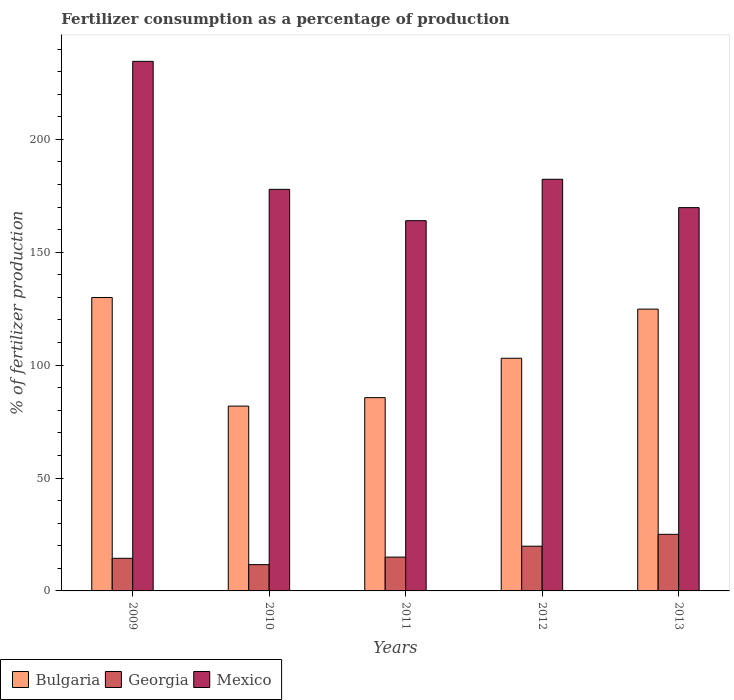How many groups of bars are there?
Provide a succinct answer. 5. Are the number of bars per tick equal to the number of legend labels?
Provide a succinct answer. Yes. Are the number of bars on each tick of the X-axis equal?
Keep it short and to the point. Yes. How many bars are there on the 2nd tick from the right?
Offer a very short reply. 3. What is the label of the 1st group of bars from the left?
Ensure brevity in your answer.  2009. What is the percentage of fertilizers consumed in Mexico in 2011?
Your answer should be compact. 163.98. Across all years, what is the maximum percentage of fertilizers consumed in Georgia?
Offer a very short reply. 25.07. Across all years, what is the minimum percentage of fertilizers consumed in Bulgaria?
Your response must be concise. 81.87. In which year was the percentage of fertilizers consumed in Mexico maximum?
Your answer should be compact. 2009. What is the total percentage of fertilizers consumed in Georgia in the graph?
Provide a short and direct response. 85.94. What is the difference between the percentage of fertilizers consumed in Georgia in 2012 and that in 2013?
Your answer should be compact. -5.26. What is the difference between the percentage of fertilizers consumed in Mexico in 2009 and the percentage of fertilizers consumed in Georgia in 2013?
Keep it short and to the point. 209.49. What is the average percentage of fertilizers consumed in Bulgaria per year?
Keep it short and to the point. 105.06. In the year 2010, what is the difference between the percentage of fertilizers consumed in Georgia and percentage of fertilizers consumed in Bulgaria?
Keep it short and to the point. -70.22. What is the ratio of the percentage of fertilizers consumed in Mexico in 2009 to that in 2013?
Your answer should be very brief. 1.38. Is the percentage of fertilizers consumed in Georgia in 2010 less than that in 2011?
Give a very brief answer. Yes. What is the difference between the highest and the second highest percentage of fertilizers consumed in Bulgaria?
Your response must be concise. 5.15. What is the difference between the highest and the lowest percentage of fertilizers consumed in Mexico?
Offer a terse response. 70.58. In how many years, is the percentage of fertilizers consumed in Bulgaria greater than the average percentage of fertilizers consumed in Bulgaria taken over all years?
Ensure brevity in your answer.  2. What does the 2nd bar from the right in 2011 represents?
Provide a short and direct response. Georgia. Is it the case that in every year, the sum of the percentage of fertilizers consumed in Bulgaria and percentage of fertilizers consumed in Mexico is greater than the percentage of fertilizers consumed in Georgia?
Make the answer very short. Yes. How many bars are there?
Provide a short and direct response. 15. What is the difference between two consecutive major ticks on the Y-axis?
Provide a succinct answer. 50. Are the values on the major ticks of Y-axis written in scientific E-notation?
Offer a very short reply. No. Does the graph contain any zero values?
Make the answer very short. No. Does the graph contain grids?
Ensure brevity in your answer.  No. Where does the legend appear in the graph?
Provide a short and direct response. Bottom left. How are the legend labels stacked?
Ensure brevity in your answer.  Horizontal. What is the title of the graph?
Your response must be concise. Fertilizer consumption as a percentage of production. What is the label or title of the X-axis?
Give a very brief answer. Years. What is the label or title of the Y-axis?
Your answer should be very brief. % of fertilizer production. What is the % of fertilizer production of Bulgaria in 2009?
Keep it short and to the point. 129.97. What is the % of fertilizer production of Georgia in 2009?
Offer a very short reply. 14.44. What is the % of fertilizer production of Mexico in 2009?
Provide a succinct answer. 234.56. What is the % of fertilizer production in Bulgaria in 2010?
Your answer should be compact. 81.87. What is the % of fertilizer production of Georgia in 2010?
Give a very brief answer. 11.64. What is the % of fertilizer production of Mexico in 2010?
Offer a very short reply. 177.87. What is the % of fertilizer production in Bulgaria in 2011?
Your answer should be very brief. 85.6. What is the % of fertilizer production of Georgia in 2011?
Give a very brief answer. 14.98. What is the % of fertilizer production of Mexico in 2011?
Ensure brevity in your answer.  163.98. What is the % of fertilizer production of Bulgaria in 2012?
Ensure brevity in your answer.  103.06. What is the % of fertilizer production in Georgia in 2012?
Provide a succinct answer. 19.81. What is the % of fertilizer production in Mexico in 2012?
Your answer should be very brief. 182.33. What is the % of fertilizer production in Bulgaria in 2013?
Your answer should be compact. 124.82. What is the % of fertilizer production in Georgia in 2013?
Provide a short and direct response. 25.07. What is the % of fertilizer production of Mexico in 2013?
Offer a very short reply. 169.77. Across all years, what is the maximum % of fertilizer production of Bulgaria?
Your answer should be compact. 129.97. Across all years, what is the maximum % of fertilizer production in Georgia?
Offer a terse response. 25.07. Across all years, what is the maximum % of fertilizer production in Mexico?
Provide a short and direct response. 234.56. Across all years, what is the minimum % of fertilizer production in Bulgaria?
Give a very brief answer. 81.87. Across all years, what is the minimum % of fertilizer production of Georgia?
Keep it short and to the point. 11.64. Across all years, what is the minimum % of fertilizer production of Mexico?
Ensure brevity in your answer.  163.98. What is the total % of fertilizer production in Bulgaria in the graph?
Give a very brief answer. 525.31. What is the total % of fertilizer production of Georgia in the graph?
Offer a terse response. 85.94. What is the total % of fertilizer production of Mexico in the graph?
Your response must be concise. 928.52. What is the difference between the % of fertilizer production of Bulgaria in 2009 and that in 2010?
Give a very brief answer. 48.1. What is the difference between the % of fertilizer production in Georgia in 2009 and that in 2010?
Your answer should be compact. 2.8. What is the difference between the % of fertilizer production in Mexico in 2009 and that in 2010?
Ensure brevity in your answer.  56.68. What is the difference between the % of fertilizer production of Bulgaria in 2009 and that in 2011?
Ensure brevity in your answer.  44.36. What is the difference between the % of fertilizer production of Georgia in 2009 and that in 2011?
Provide a succinct answer. -0.54. What is the difference between the % of fertilizer production of Mexico in 2009 and that in 2011?
Your answer should be compact. 70.58. What is the difference between the % of fertilizer production in Bulgaria in 2009 and that in 2012?
Offer a terse response. 26.91. What is the difference between the % of fertilizer production of Georgia in 2009 and that in 2012?
Make the answer very short. -5.37. What is the difference between the % of fertilizer production in Mexico in 2009 and that in 2012?
Offer a very short reply. 52.23. What is the difference between the % of fertilizer production in Bulgaria in 2009 and that in 2013?
Make the answer very short. 5.15. What is the difference between the % of fertilizer production of Georgia in 2009 and that in 2013?
Provide a short and direct response. -10.62. What is the difference between the % of fertilizer production of Mexico in 2009 and that in 2013?
Give a very brief answer. 64.78. What is the difference between the % of fertilizer production in Bulgaria in 2010 and that in 2011?
Offer a very short reply. -3.74. What is the difference between the % of fertilizer production in Georgia in 2010 and that in 2011?
Give a very brief answer. -3.34. What is the difference between the % of fertilizer production in Mexico in 2010 and that in 2011?
Offer a very short reply. 13.89. What is the difference between the % of fertilizer production of Bulgaria in 2010 and that in 2012?
Ensure brevity in your answer.  -21.19. What is the difference between the % of fertilizer production in Georgia in 2010 and that in 2012?
Provide a succinct answer. -8.17. What is the difference between the % of fertilizer production of Mexico in 2010 and that in 2012?
Ensure brevity in your answer.  -4.46. What is the difference between the % of fertilizer production in Bulgaria in 2010 and that in 2013?
Your answer should be compact. -42.95. What is the difference between the % of fertilizer production of Georgia in 2010 and that in 2013?
Provide a succinct answer. -13.42. What is the difference between the % of fertilizer production of Mexico in 2010 and that in 2013?
Your answer should be compact. 8.1. What is the difference between the % of fertilizer production in Bulgaria in 2011 and that in 2012?
Make the answer very short. -17.45. What is the difference between the % of fertilizer production of Georgia in 2011 and that in 2012?
Offer a very short reply. -4.83. What is the difference between the % of fertilizer production of Mexico in 2011 and that in 2012?
Your answer should be very brief. -18.35. What is the difference between the % of fertilizer production in Bulgaria in 2011 and that in 2013?
Offer a terse response. -39.22. What is the difference between the % of fertilizer production in Georgia in 2011 and that in 2013?
Your answer should be compact. -10.09. What is the difference between the % of fertilizer production of Mexico in 2011 and that in 2013?
Keep it short and to the point. -5.79. What is the difference between the % of fertilizer production in Bulgaria in 2012 and that in 2013?
Keep it short and to the point. -21.76. What is the difference between the % of fertilizer production in Georgia in 2012 and that in 2013?
Offer a terse response. -5.26. What is the difference between the % of fertilizer production in Mexico in 2012 and that in 2013?
Give a very brief answer. 12.56. What is the difference between the % of fertilizer production in Bulgaria in 2009 and the % of fertilizer production in Georgia in 2010?
Your answer should be very brief. 118.32. What is the difference between the % of fertilizer production in Bulgaria in 2009 and the % of fertilizer production in Mexico in 2010?
Offer a very short reply. -47.91. What is the difference between the % of fertilizer production in Georgia in 2009 and the % of fertilizer production in Mexico in 2010?
Your answer should be very brief. -163.43. What is the difference between the % of fertilizer production of Bulgaria in 2009 and the % of fertilizer production of Georgia in 2011?
Your answer should be very brief. 114.99. What is the difference between the % of fertilizer production of Bulgaria in 2009 and the % of fertilizer production of Mexico in 2011?
Provide a succinct answer. -34.01. What is the difference between the % of fertilizer production in Georgia in 2009 and the % of fertilizer production in Mexico in 2011?
Ensure brevity in your answer.  -149.54. What is the difference between the % of fertilizer production in Bulgaria in 2009 and the % of fertilizer production in Georgia in 2012?
Your response must be concise. 110.15. What is the difference between the % of fertilizer production in Bulgaria in 2009 and the % of fertilizer production in Mexico in 2012?
Ensure brevity in your answer.  -52.37. What is the difference between the % of fertilizer production in Georgia in 2009 and the % of fertilizer production in Mexico in 2012?
Your answer should be very brief. -167.89. What is the difference between the % of fertilizer production of Bulgaria in 2009 and the % of fertilizer production of Georgia in 2013?
Offer a terse response. 104.9. What is the difference between the % of fertilizer production of Bulgaria in 2009 and the % of fertilizer production of Mexico in 2013?
Offer a very short reply. -39.81. What is the difference between the % of fertilizer production in Georgia in 2009 and the % of fertilizer production in Mexico in 2013?
Your answer should be compact. -155.33. What is the difference between the % of fertilizer production in Bulgaria in 2010 and the % of fertilizer production in Georgia in 2011?
Provide a succinct answer. 66.89. What is the difference between the % of fertilizer production of Bulgaria in 2010 and the % of fertilizer production of Mexico in 2011?
Give a very brief answer. -82.11. What is the difference between the % of fertilizer production in Georgia in 2010 and the % of fertilizer production in Mexico in 2011?
Offer a terse response. -152.34. What is the difference between the % of fertilizer production in Bulgaria in 2010 and the % of fertilizer production in Georgia in 2012?
Give a very brief answer. 62.05. What is the difference between the % of fertilizer production of Bulgaria in 2010 and the % of fertilizer production of Mexico in 2012?
Your answer should be compact. -100.47. What is the difference between the % of fertilizer production in Georgia in 2010 and the % of fertilizer production in Mexico in 2012?
Keep it short and to the point. -170.69. What is the difference between the % of fertilizer production of Bulgaria in 2010 and the % of fertilizer production of Georgia in 2013?
Offer a very short reply. 56.8. What is the difference between the % of fertilizer production in Bulgaria in 2010 and the % of fertilizer production in Mexico in 2013?
Offer a terse response. -87.91. What is the difference between the % of fertilizer production of Georgia in 2010 and the % of fertilizer production of Mexico in 2013?
Keep it short and to the point. -158.13. What is the difference between the % of fertilizer production of Bulgaria in 2011 and the % of fertilizer production of Georgia in 2012?
Give a very brief answer. 65.79. What is the difference between the % of fertilizer production of Bulgaria in 2011 and the % of fertilizer production of Mexico in 2012?
Offer a very short reply. -96.73. What is the difference between the % of fertilizer production in Georgia in 2011 and the % of fertilizer production in Mexico in 2012?
Provide a succinct answer. -167.35. What is the difference between the % of fertilizer production of Bulgaria in 2011 and the % of fertilizer production of Georgia in 2013?
Provide a short and direct response. 60.54. What is the difference between the % of fertilizer production in Bulgaria in 2011 and the % of fertilizer production in Mexico in 2013?
Offer a terse response. -84.17. What is the difference between the % of fertilizer production in Georgia in 2011 and the % of fertilizer production in Mexico in 2013?
Offer a very short reply. -154.79. What is the difference between the % of fertilizer production in Bulgaria in 2012 and the % of fertilizer production in Georgia in 2013?
Your answer should be very brief. 77.99. What is the difference between the % of fertilizer production of Bulgaria in 2012 and the % of fertilizer production of Mexico in 2013?
Your answer should be compact. -66.72. What is the difference between the % of fertilizer production of Georgia in 2012 and the % of fertilizer production of Mexico in 2013?
Offer a terse response. -149.96. What is the average % of fertilizer production of Bulgaria per year?
Provide a short and direct response. 105.06. What is the average % of fertilizer production of Georgia per year?
Ensure brevity in your answer.  17.19. What is the average % of fertilizer production of Mexico per year?
Provide a short and direct response. 185.7. In the year 2009, what is the difference between the % of fertilizer production in Bulgaria and % of fertilizer production in Georgia?
Your answer should be compact. 115.52. In the year 2009, what is the difference between the % of fertilizer production in Bulgaria and % of fertilizer production in Mexico?
Your response must be concise. -104.59. In the year 2009, what is the difference between the % of fertilizer production of Georgia and % of fertilizer production of Mexico?
Provide a short and direct response. -220.11. In the year 2010, what is the difference between the % of fertilizer production of Bulgaria and % of fertilizer production of Georgia?
Offer a very short reply. 70.22. In the year 2010, what is the difference between the % of fertilizer production in Bulgaria and % of fertilizer production in Mexico?
Make the answer very short. -96.01. In the year 2010, what is the difference between the % of fertilizer production in Georgia and % of fertilizer production in Mexico?
Ensure brevity in your answer.  -166.23. In the year 2011, what is the difference between the % of fertilizer production in Bulgaria and % of fertilizer production in Georgia?
Provide a short and direct response. 70.62. In the year 2011, what is the difference between the % of fertilizer production in Bulgaria and % of fertilizer production in Mexico?
Your response must be concise. -78.38. In the year 2011, what is the difference between the % of fertilizer production of Georgia and % of fertilizer production of Mexico?
Keep it short and to the point. -149. In the year 2012, what is the difference between the % of fertilizer production in Bulgaria and % of fertilizer production in Georgia?
Make the answer very short. 83.24. In the year 2012, what is the difference between the % of fertilizer production in Bulgaria and % of fertilizer production in Mexico?
Provide a short and direct response. -79.28. In the year 2012, what is the difference between the % of fertilizer production in Georgia and % of fertilizer production in Mexico?
Ensure brevity in your answer.  -162.52. In the year 2013, what is the difference between the % of fertilizer production of Bulgaria and % of fertilizer production of Georgia?
Ensure brevity in your answer.  99.75. In the year 2013, what is the difference between the % of fertilizer production of Bulgaria and % of fertilizer production of Mexico?
Give a very brief answer. -44.96. In the year 2013, what is the difference between the % of fertilizer production of Georgia and % of fertilizer production of Mexico?
Provide a succinct answer. -144.71. What is the ratio of the % of fertilizer production of Bulgaria in 2009 to that in 2010?
Offer a terse response. 1.59. What is the ratio of the % of fertilizer production in Georgia in 2009 to that in 2010?
Provide a short and direct response. 1.24. What is the ratio of the % of fertilizer production of Mexico in 2009 to that in 2010?
Ensure brevity in your answer.  1.32. What is the ratio of the % of fertilizer production of Bulgaria in 2009 to that in 2011?
Keep it short and to the point. 1.52. What is the ratio of the % of fertilizer production in Georgia in 2009 to that in 2011?
Your answer should be compact. 0.96. What is the ratio of the % of fertilizer production of Mexico in 2009 to that in 2011?
Your answer should be very brief. 1.43. What is the ratio of the % of fertilizer production of Bulgaria in 2009 to that in 2012?
Your answer should be compact. 1.26. What is the ratio of the % of fertilizer production of Georgia in 2009 to that in 2012?
Make the answer very short. 0.73. What is the ratio of the % of fertilizer production in Mexico in 2009 to that in 2012?
Your answer should be very brief. 1.29. What is the ratio of the % of fertilizer production of Bulgaria in 2009 to that in 2013?
Keep it short and to the point. 1.04. What is the ratio of the % of fertilizer production in Georgia in 2009 to that in 2013?
Offer a very short reply. 0.58. What is the ratio of the % of fertilizer production of Mexico in 2009 to that in 2013?
Give a very brief answer. 1.38. What is the ratio of the % of fertilizer production of Bulgaria in 2010 to that in 2011?
Provide a short and direct response. 0.96. What is the ratio of the % of fertilizer production of Georgia in 2010 to that in 2011?
Provide a succinct answer. 0.78. What is the ratio of the % of fertilizer production of Mexico in 2010 to that in 2011?
Provide a succinct answer. 1.08. What is the ratio of the % of fertilizer production of Bulgaria in 2010 to that in 2012?
Offer a terse response. 0.79. What is the ratio of the % of fertilizer production of Georgia in 2010 to that in 2012?
Give a very brief answer. 0.59. What is the ratio of the % of fertilizer production of Mexico in 2010 to that in 2012?
Make the answer very short. 0.98. What is the ratio of the % of fertilizer production in Bulgaria in 2010 to that in 2013?
Make the answer very short. 0.66. What is the ratio of the % of fertilizer production in Georgia in 2010 to that in 2013?
Your response must be concise. 0.46. What is the ratio of the % of fertilizer production of Mexico in 2010 to that in 2013?
Offer a very short reply. 1.05. What is the ratio of the % of fertilizer production in Bulgaria in 2011 to that in 2012?
Give a very brief answer. 0.83. What is the ratio of the % of fertilizer production in Georgia in 2011 to that in 2012?
Your answer should be compact. 0.76. What is the ratio of the % of fertilizer production of Mexico in 2011 to that in 2012?
Keep it short and to the point. 0.9. What is the ratio of the % of fertilizer production in Bulgaria in 2011 to that in 2013?
Your answer should be very brief. 0.69. What is the ratio of the % of fertilizer production of Georgia in 2011 to that in 2013?
Offer a very short reply. 0.6. What is the ratio of the % of fertilizer production of Mexico in 2011 to that in 2013?
Provide a succinct answer. 0.97. What is the ratio of the % of fertilizer production in Bulgaria in 2012 to that in 2013?
Provide a short and direct response. 0.83. What is the ratio of the % of fertilizer production in Georgia in 2012 to that in 2013?
Your answer should be very brief. 0.79. What is the ratio of the % of fertilizer production of Mexico in 2012 to that in 2013?
Make the answer very short. 1.07. What is the difference between the highest and the second highest % of fertilizer production in Bulgaria?
Offer a terse response. 5.15. What is the difference between the highest and the second highest % of fertilizer production of Georgia?
Provide a succinct answer. 5.26. What is the difference between the highest and the second highest % of fertilizer production in Mexico?
Provide a succinct answer. 52.23. What is the difference between the highest and the lowest % of fertilizer production of Bulgaria?
Provide a short and direct response. 48.1. What is the difference between the highest and the lowest % of fertilizer production in Georgia?
Provide a short and direct response. 13.42. What is the difference between the highest and the lowest % of fertilizer production in Mexico?
Provide a short and direct response. 70.58. 